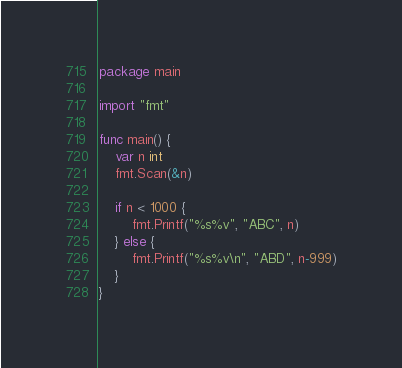Convert code to text. <code><loc_0><loc_0><loc_500><loc_500><_Go_>package main

import "fmt"

func main() {
	var n int
	fmt.Scan(&n)

	if n < 1000 {
		fmt.Printf("%s%v", "ABC", n)
	} else {
		fmt.Printf("%s%v\n", "ABD", n-999)
	}
}
</code> 